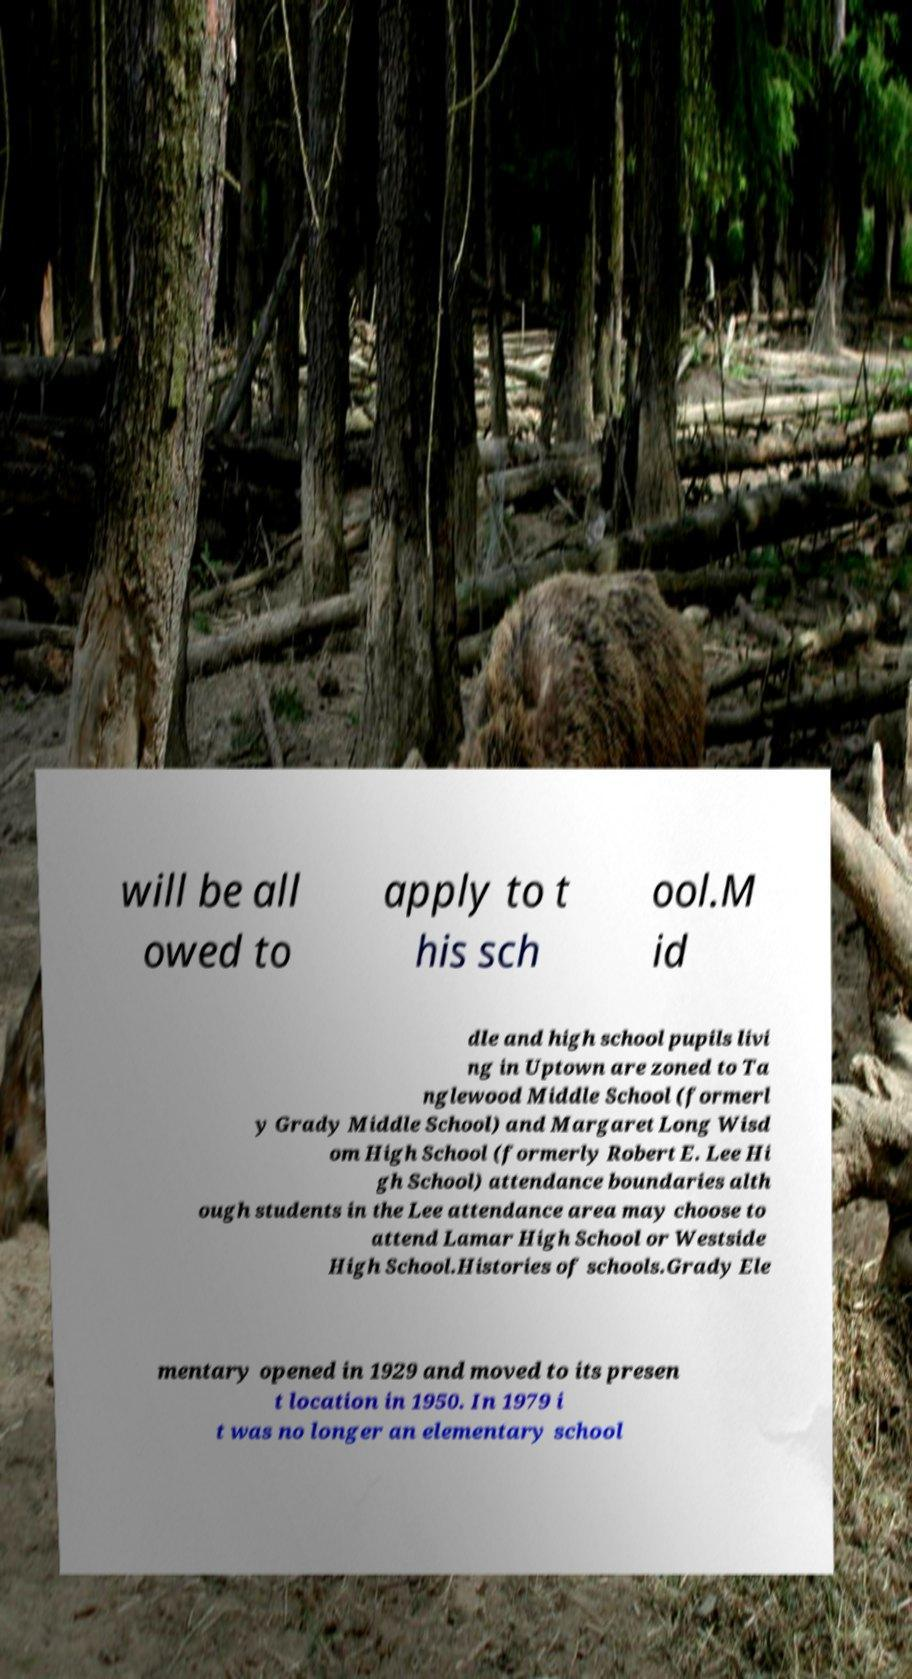There's text embedded in this image that I need extracted. Can you transcribe it verbatim? will be all owed to apply to t his sch ool.M id dle and high school pupils livi ng in Uptown are zoned to Ta nglewood Middle School (formerl y Grady Middle School) and Margaret Long Wisd om High School (formerly Robert E. Lee Hi gh School) attendance boundaries alth ough students in the Lee attendance area may choose to attend Lamar High School or Westside High School.Histories of schools.Grady Ele mentary opened in 1929 and moved to its presen t location in 1950. In 1979 i t was no longer an elementary school 